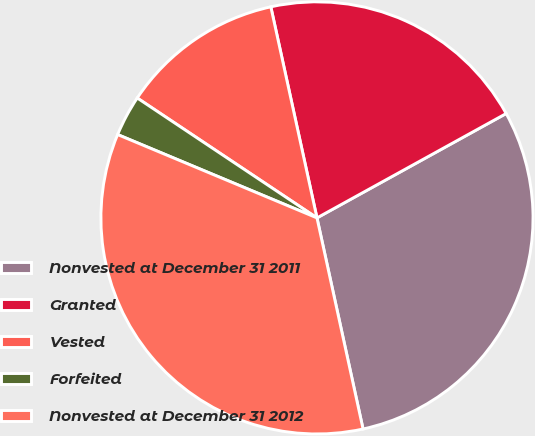Convert chart to OTSL. <chart><loc_0><loc_0><loc_500><loc_500><pie_chart><fcel>Nonvested at December 31 2011<fcel>Granted<fcel>Vested<fcel>Forfeited<fcel>Nonvested at December 31 2012<nl><fcel>29.6%<fcel>20.4%<fcel>12.21%<fcel>3.06%<fcel>34.72%<nl></chart> 